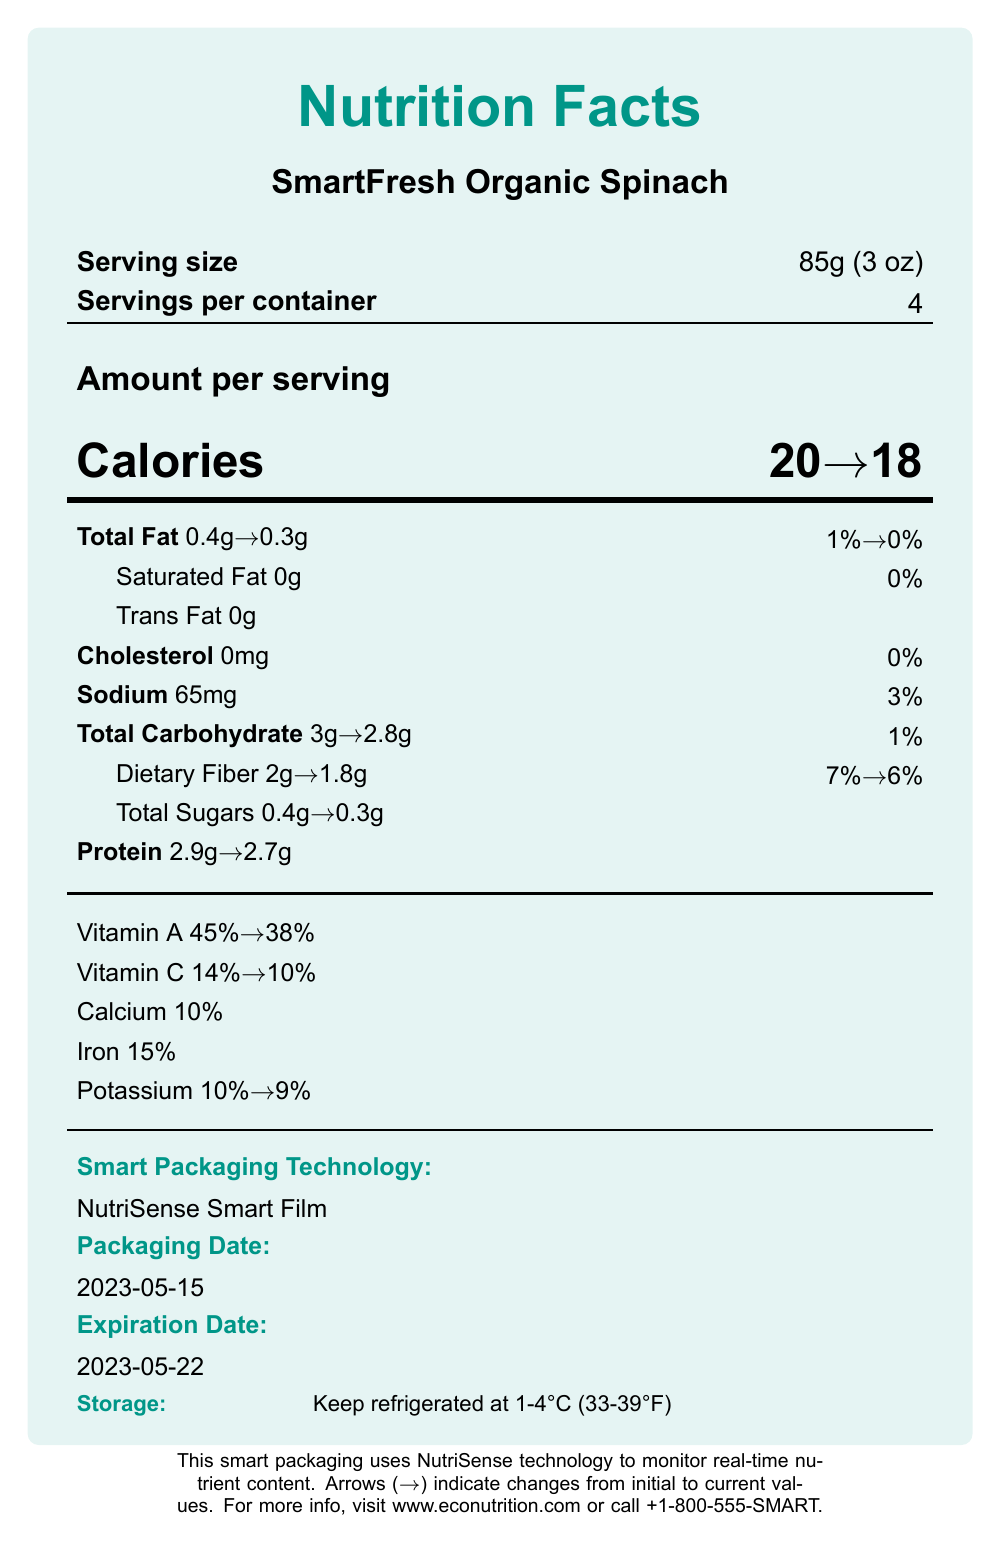how much sodium is in one serving? The document lists the sodium content per serving as 65mg.
Answer: 65mg what is the serving size? The document specifies that the serving size is 85g (3 oz).
Answer: 85g (3 oz) how many servings are in one container? The document indicates that there are 4 servings per container.
Answer: 4 what amount of dietary fiber is listed for one serving initially and in its degraded form? According to the document, the dietary fiber content is initially 2g per serving, and it degrades to 1.8g.
Answer: Initially: 2g, Degraded: 1.8g what is the initial protein content per serving? The document shows that the initial protein content per serving is 2.9g.
Answer: 2.9g how many calories are there per serving after nutrient degradation? A. 20 B. 18 C. 22 D. 15 The document indicates that the calories per serving degrade from 20 to 18.
Answer: B what vitamin shows the highest percentage of degradation from its initial value? A. Vitamin A B. Vitamin C C. Calcium D. Iron Vitamin A degrades from 45% to 38%, which is a 7% decline, the highest among the vitamins listed.
Answer: A are there any changes in the sodium content between initial and degraded states? The sodium content remains the same at 65mg.
Answer: No does SmartFresh Organic Spinach contain any trans fat? The document states that both the initial and degraded values of trans fat are 0g.
Answer: No summarize the purpose and key features of this smart packaging product. The document describes "SmartFresh Organic Spinach" and its NutriSense Smart Film technology. It details nutrient contents initially and in their degraded form, highlights the benefits of real-time monitoring, and mentions societal implications and manufacturer information.
Answer: The document provides nutrition facts for "SmartFresh Organic Spinach," which uses NutriSense Smart Film to monitor real-time nutrient degradation. The smart packaging aims to improve nutrition tracking, enhance food safety, extend shelf life, reduce food waste, and increase consumer awareness. It lists initial and degraded nutrient values and emphasizes the importance of proper storage conditions. what is the packaging date of the product? The document shows that the packaging date is 2023-05-15.
Answer: 2023-05-15 is the cholesterol level affected by nutrient degradation? The document indicates that the cholesterol level remains at 0mg both initially and in its degraded state.
Answer: No what are the societal implications of this smart packaging technology? The document lists these societal implications as direct effects of using the smart packaging technology.
Answer: Improved nutrition tracking, food safety enhancement, environmental sustainability, digital divide in food access how does temperature impact the nutrient content of the product? Although temperature is listed as a degradation factor, the document does not provide specific details on how temperature impacts nutrient content.
Answer: Not enough information explain the significance of the arrows (→) used in the document. The document uses arrows to visually represent the change in each nutrient's content due to degradation over time or other factors. For example, calories change from 20 to 18, shown as 20→18.
Answer: The arrows indicate changes in nutrient content from the initial values to the degraded values. 